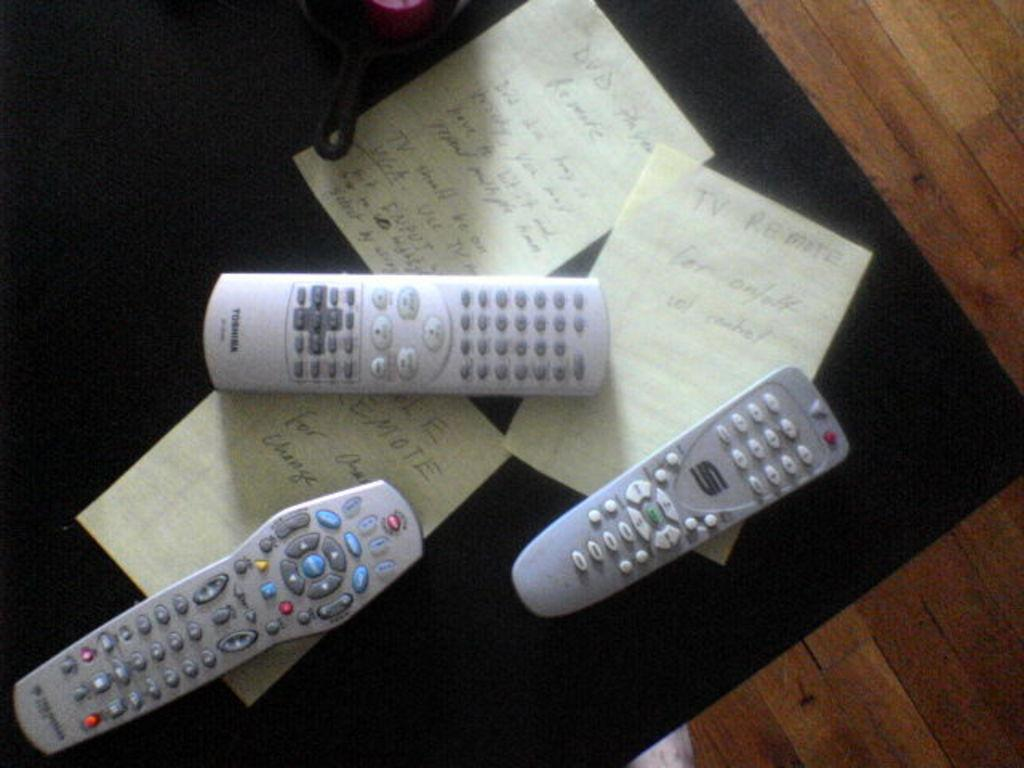Provide a one-sentence caption for the provided image. Three remotes are on a coffee table with notes that say TV Remote. 